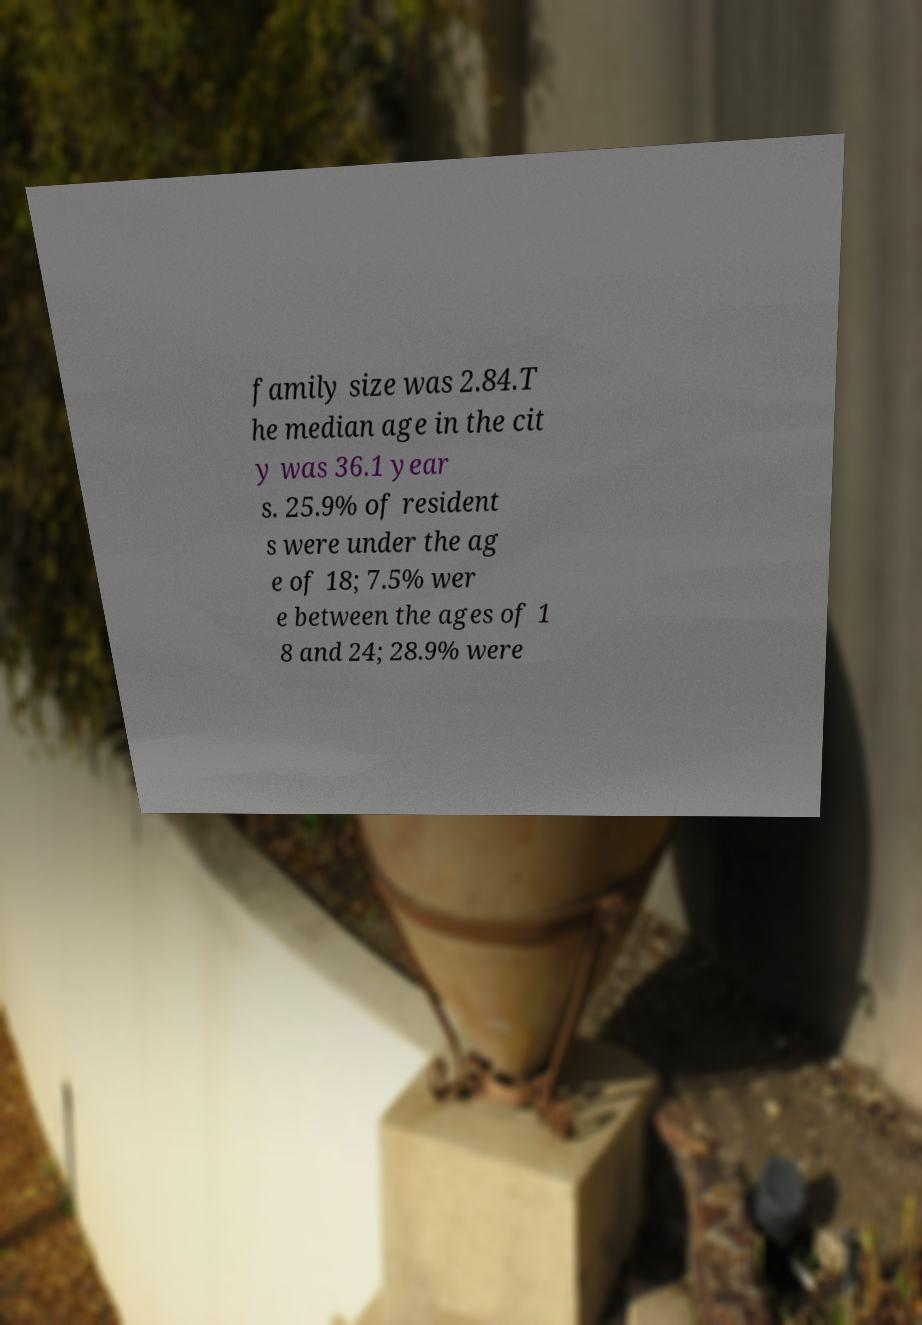There's text embedded in this image that I need extracted. Can you transcribe it verbatim? family size was 2.84.T he median age in the cit y was 36.1 year s. 25.9% of resident s were under the ag e of 18; 7.5% wer e between the ages of 1 8 and 24; 28.9% were 